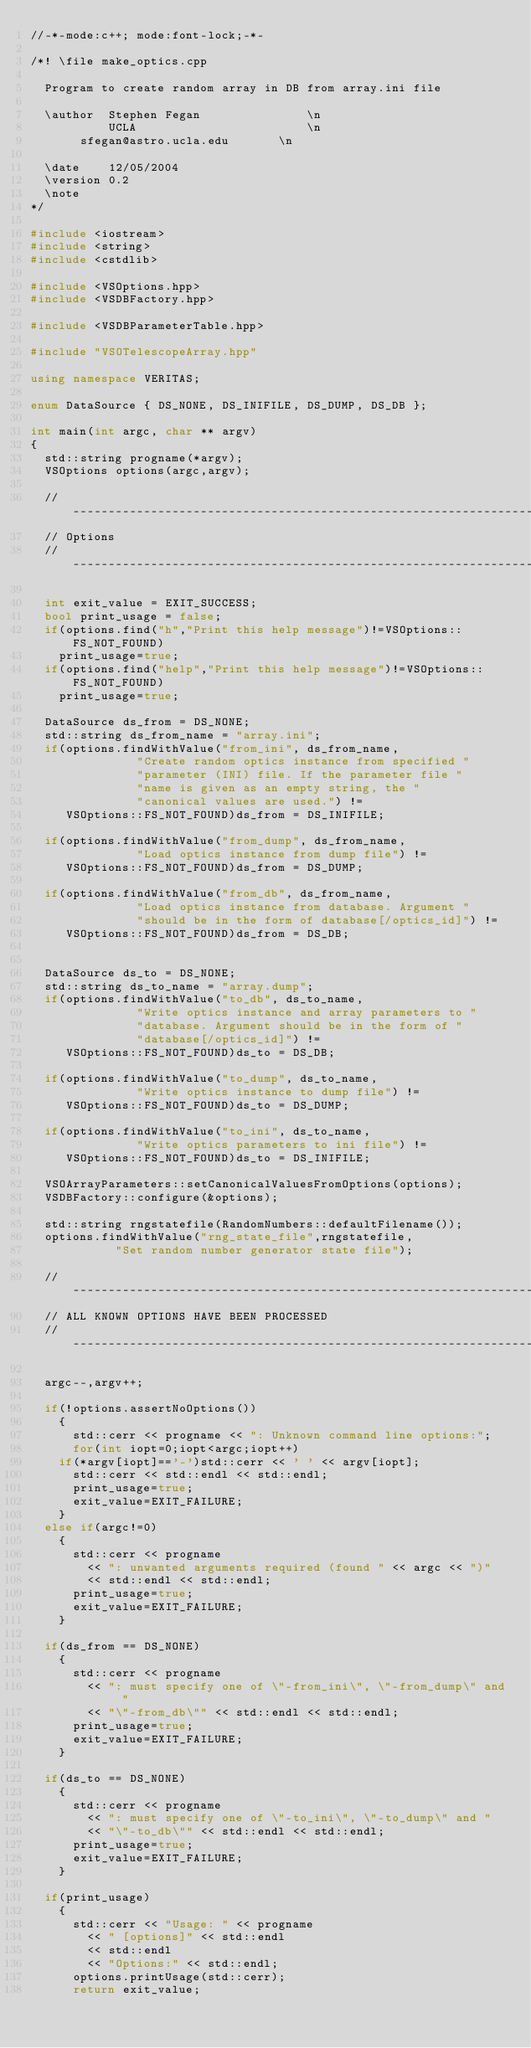<code> <loc_0><loc_0><loc_500><loc_500><_C++_>//-*-mode:c++; mode:font-lock;-*-

/*! \file make_optics.cpp

  Program to create random array in DB from array.ini file

  \author  Stephen Fegan               \n
           UCLA                        \n
	   sfegan@astro.ucla.edu       \n

  \date    12/05/2004
  \version 0.2
  \note
*/

#include <iostream>
#include <string>
#include <cstdlib>

#include <VSOptions.hpp>
#include <VSDBFactory.hpp>

#include <VSDBParameterTable.hpp>

#include "VSOTelescopeArray.hpp"

using namespace VERITAS;

enum DataSource { DS_NONE, DS_INIFILE, DS_DUMP, DS_DB };

int main(int argc, char ** argv)
{
  std::string progname(*argv);
  VSOptions options(argc,argv);

  // --------------------------------------------------------------------------
  // Options
  // --------------------------------------------------------------------------

  int exit_value = EXIT_SUCCESS;
  bool print_usage = false;
  if(options.find("h","Print this help message")!=VSOptions::FS_NOT_FOUND)
    print_usage=true;
  if(options.find("help","Print this help message")!=VSOptions::FS_NOT_FOUND)
    print_usage=true;

  DataSource ds_from = DS_NONE;
  std::string ds_from_name = "array.ini";
  if(options.findWithValue("from_ini", ds_from_name,
			   "Create random optics instance from specified "
			   "parameter (INI) file. If the parameter file "
			   "name is given as an empty string, the "
			   "canonical values are used.") != 
     VSOptions::FS_NOT_FOUND)ds_from = DS_INIFILE;

  if(options.findWithValue("from_dump", ds_from_name,
			   "Load optics instance from dump file") != 
     VSOptions::FS_NOT_FOUND)ds_from = DS_DUMP;

  if(options.findWithValue("from_db", ds_from_name,
			   "Load optics instance from database. Argument "
			   "should be in the form of database[/optics_id]") != 
     VSOptions::FS_NOT_FOUND)ds_from = DS_DB;


  DataSource ds_to = DS_NONE;
  std::string ds_to_name = "array.dump";
  if(options.findWithValue("to_db", ds_to_name,
			   "Write optics instance and array parameters to "
			   "database. Argument should be in the form of "
			   "database[/optics_id]") != 
     VSOptions::FS_NOT_FOUND)ds_to = DS_DB;

  if(options.findWithValue("to_dump", ds_to_name,
			   "Write optics instance to dump file") != 
     VSOptions::FS_NOT_FOUND)ds_to = DS_DUMP;

  if(options.findWithValue("to_ini", ds_to_name,
			   "Write optics parameters to ini file") != 
     VSOptions::FS_NOT_FOUND)ds_to = DS_INIFILE;

  VSOArrayParameters::setCanonicalValuesFromOptions(options);
  VSDBFactory::configure(&options);

  std::string rngstatefile(RandomNumbers::defaultFilename());
  options.findWithValue("rng_state_file",rngstatefile,
			"Set random number generator state file");
  
  // --------------------------------------------------------------------------
  // ALL KNOWN OPTIONS HAVE BEEN PROCESSED
  // --------------------------------------------------------------------------

  argc--,argv++;

  if(!options.assertNoOptions())
    {
      std::cerr << progname << ": Unknown command line options:";
      for(int iopt=0;iopt<argc;iopt++)
	if(*argv[iopt]=='-')std::cerr << ' ' << argv[iopt];
      std::cerr << std::endl << std::endl;
      print_usage=true;
      exit_value=EXIT_FAILURE;
    }
  else if(argc!=0)
    {
      std::cerr << progname 
		<< ": unwanted arguments required (found " << argc << ")"
		<< std::endl << std::endl;
      print_usage=true;
      exit_value=EXIT_FAILURE;
    }  

  if(ds_from == DS_NONE)
    {
      std::cerr << progname 
		<< ": must specify one of \"-from_ini\", \"-from_dump\" and "
		<< "\"-from_db\"" << std::endl << std::endl;
      print_usage=true;
      exit_value=EXIT_FAILURE;      
    }

  if(ds_to == DS_NONE)
    {
      std::cerr << progname 
		<< ": must specify one of \"-to_ini\", \"-to_dump\" and "
		<< "\"-to_db\"" << std::endl << std::endl;
      print_usage=true;
      exit_value=EXIT_FAILURE;      
    }

  if(print_usage)
    {
      std::cerr << "Usage: " << progname 
		<< " [options]" << std::endl
		<< std::endl
		<< "Options:" << std::endl;
      options.printUsage(std::cerr);
      return exit_value;</code> 